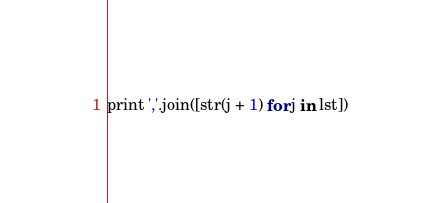Convert code to text. <code><loc_0><loc_0><loc_500><loc_500><_Python_>print ','.join([str(j + 1) for j in lst])</code> 